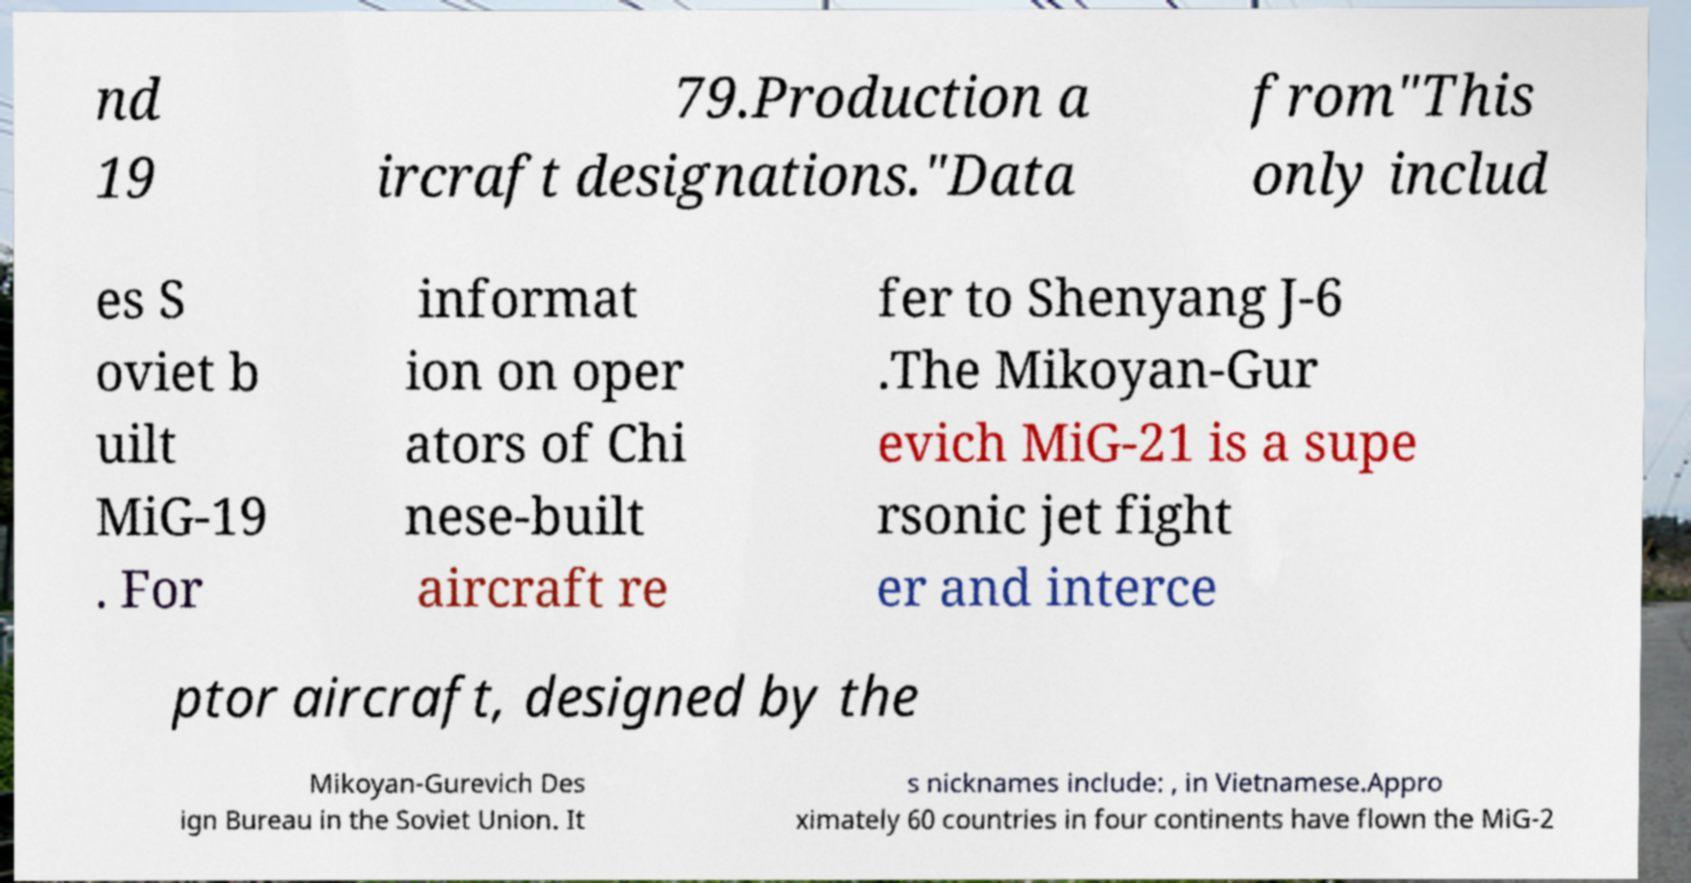I need the written content from this picture converted into text. Can you do that? nd 19 79.Production a ircraft designations."Data from"This only includ es S oviet b uilt MiG-19 . For informat ion on oper ators of Chi nese-built aircraft re fer to Shenyang J-6 .The Mikoyan-Gur evich MiG-21 is a supe rsonic jet fight er and interce ptor aircraft, designed by the Mikoyan-Gurevich Des ign Bureau in the Soviet Union. It s nicknames include: , in Vietnamese.Appro ximately 60 countries in four continents have flown the MiG-2 